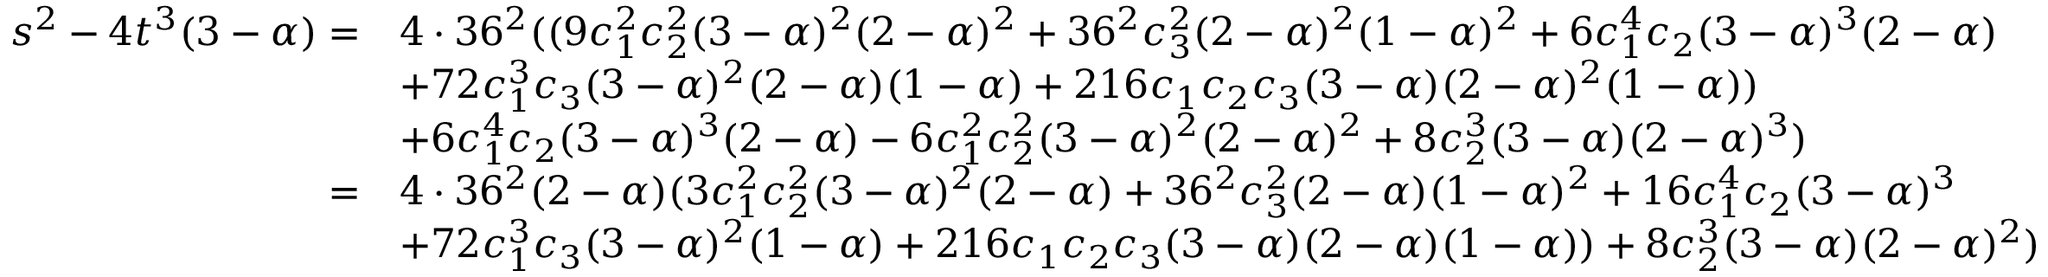<formula> <loc_0><loc_0><loc_500><loc_500>\begin{array} { r l } { s ^ { 2 } - 4 t ^ { 3 } ( 3 - \alpha ) = } & { 4 \cdot 3 6 ^ { 2 } ( ( 9 c _ { 1 } ^ { 2 } c _ { 2 } ^ { 2 } ( 3 - \alpha ) ^ { 2 } ( 2 - \alpha ) ^ { 2 } + 3 6 ^ { 2 } c _ { 3 } ^ { 2 } ( 2 - \alpha ) ^ { 2 } ( 1 - \alpha ) ^ { 2 } + 6 c _ { 1 } ^ { 4 } c _ { 2 } ( 3 - \alpha ) ^ { 3 } ( 2 - \alpha ) } \\ & { + 7 2 c _ { 1 } ^ { 3 } c _ { 3 } ( 3 - \alpha ) ^ { 2 } ( 2 - \alpha ) ( 1 - \alpha ) + 2 1 6 c _ { 1 } c _ { 2 } c _ { 3 } ( 3 - \alpha ) ( 2 - \alpha ) ^ { 2 } ( 1 - \alpha ) ) } \\ & { + 6 c _ { 1 } ^ { 4 } c _ { 2 } ( 3 - \alpha ) ^ { 3 } ( 2 - \alpha ) - 6 c _ { 1 } ^ { 2 } c _ { 2 } ^ { 2 } ( 3 - \alpha ) ^ { 2 } ( 2 - \alpha ) ^ { 2 } + 8 c _ { 2 } ^ { 3 } ( 3 - \alpha ) ( 2 - \alpha ) ^ { 3 } ) } \\ { = } & { 4 \cdot 3 6 ^ { 2 } ( 2 - \alpha ) ( 3 c _ { 1 } ^ { 2 } c _ { 2 } ^ { 2 } ( 3 - \alpha ) ^ { 2 } ( 2 - \alpha ) + 3 6 ^ { 2 } c _ { 3 } ^ { 2 } ( 2 - \alpha ) ( 1 - \alpha ) ^ { 2 } + 1 6 c _ { 1 } ^ { 4 } c _ { 2 } ( 3 - \alpha ) ^ { 3 } } \\ & { + 7 2 c _ { 1 } ^ { 3 } c _ { 3 } ( 3 - \alpha ) ^ { 2 } ( 1 - \alpha ) + 2 1 6 c _ { 1 } c _ { 2 } c _ { 3 } ( 3 - \alpha ) ( 2 - \alpha ) ( 1 - \alpha ) ) + 8 c _ { 2 } ^ { 3 } ( 3 - \alpha ) ( 2 - \alpha ) ^ { 2 } ) } \end{array}</formula> 